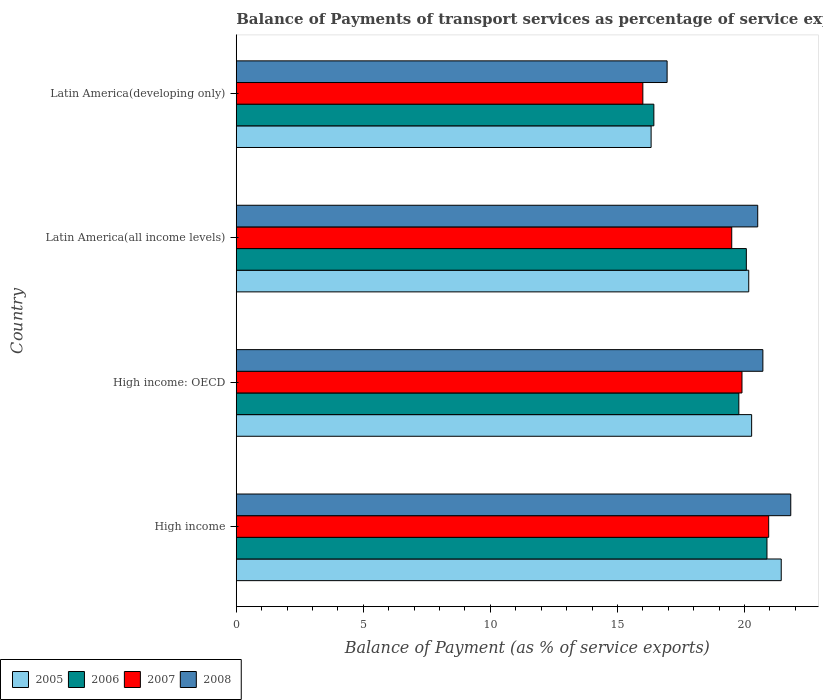How many groups of bars are there?
Offer a terse response. 4. Are the number of bars per tick equal to the number of legend labels?
Give a very brief answer. Yes. How many bars are there on the 4th tick from the bottom?
Offer a very short reply. 4. What is the label of the 4th group of bars from the top?
Your answer should be very brief. High income. What is the balance of payments of transport services in 2007 in High income?
Make the answer very short. 20.95. Across all countries, what is the maximum balance of payments of transport services in 2008?
Make the answer very short. 21.82. Across all countries, what is the minimum balance of payments of transport services in 2008?
Make the answer very short. 16.95. In which country was the balance of payments of transport services in 2006 maximum?
Make the answer very short. High income. In which country was the balance of payments of transport services in 2005 minimum?
Offer a terse response. Latin America(developing only). What is the total balance of payments of transport services in 2008 in the graph?
Make the answer very short. 80.01. What is the difference between the balance of payments of transport services in 2005 in High income and that in Latin America(all income levels)?
Keep it short and to the point. 1.28. What is the difference between the balance of payments of transport services in 2007 in Latin America(developing only) and the balance of payments of transport services in 2006 in High income: OECD?
Make the answer very short. -3.78. What is the average balance of payments of transport services in 2006 per country?
Ensure brevity in your answer.  19.29. What is the difference between the balance of payments of transport services in 2008 and balance of payments of transport services in 2007 in Latin America(all income levels)?
Your answer should be compact. 1.02. In how many countries, is the balance of payments of transport services in 2006 greater than 18 %?
Provide a short and direct response. 3. What is the ratio of the balance of payments of transport services in 2008 in High income to that in High income: OECD?
Your response must be concise. 1.05. Is the balance of payments of transport services in 2005 in High income: OECD less than that in Latin America(developing only)?
Ensure brevity in your answer.  No. Is the difference between the balance of payments of transport services in 2008 in High income: OECD and Latin America(developing only) greater than the difference between the balance of payments of transport services in 2007 in High income: OECD and Latin America(developing only)?
Offer a terse response. No. What is the difference between the highest and the second highest balance of payments of transport services in 2008?
Give a very brief answer. 1.1. What is the difference between the highest and the lowest balance of payments of transport services in 2006?
Make the answer very short. 4.45. In how many countries, is the balance of payments of transport services in 2006 greater than the average balance of payments of transport services in 2006 taken over all countries?
Ensure brevity in your answer.  3. Is the sum of the balance of payments of transport services in 2006 in Latin America(all income levels) and Latin America(developing only) greater than the maximum balance of payments of transport services in 2007 across all countries?
Keep it short and to the point. Yes. What does the 3rd bar from the bottom in High income represents?
Offer a terse response. 2007. Is it the case that in every country, the sum of the balance of payments of transport services in 2007 and balance of payments of transport services in 2005 is greater than the balance of payments of transport services in 2006?
Your answer should be very brief. Yes. How many bars are there?
Provide a succinct answer. 16. Are all the bars in the graph horizontal?
Ensure brevity in your answer.  Yes. How many countries are there in the graph?
Keep it short and to the point. 4. Where does the legend appear in the graph?
Offer a terse response. Bottom left. How many legend labels are there?
Your answer should be compact. 4. How are the legend labels stacked?
Ensure brevity in your answer.  Horizontal. What is the title of the graph?
Ensure brevity in your answer.  Balance of Payments of transport services as percentage of service exports. Does "2011" appear as one of the legend labels in the graph?
Ensure brevity in your answer.  No. What is the label or title of the X-axis?
Provide a succinct answer. Balance of Payment (as % of service exports). What is the Balance of Payment (as % of service exports) in 2005 in High income?
Your answer should be compact. 21.44. What is the Balance of Payment (as % of service exports) in 2006 in High income?
Offer a very short reply. 20.88. What is the Balance of Payment (as % of service exports) of 2007 in High income?
Provide a succinct answer. 20.95. What is the Balance of Payment (as % of service exports) of 2008 in High income?
Provide a succinct answer. 21.82. What is the Balance of Payment (as % of service exports) of 2005 in High income: OECD?
Offer a very short reply. 20.28. What is the Balance of Payment (as % of service exports) in 2006 in High income: OECD?
Give a very brief answer. 19.78. What is the Balance of Payment (as % of service exports) of 2007 in High income: OECD?
Offer a terse response. 19.9. What is the Balance of Payment (as % of service exports) of 2008 in High income: OECD?
Give a very brief answer. 20.72. What is the Balance of Payment (as % of service exports) in 2005 in Latin America(all income levels)?
Your answer should be very brief. 20.17. What is the Balance of Payment (as % of service exports) in 2006 in Latin America(all income levels)?
Offer a very short reply. 20.07. What is the Balance of Payment (as % of service exports) of 2007 in Latin America(all income levels)?
Provide a short and direct response. 19.5. What is the Balance of Payment (as % of service exports) in 2008 in Latin America(all income levels)?
Ensure brevity in your answer.  20.52. What is the Balance of Payment (as % of service exports) in 2005 in Latin America(developing only)?
Make the answer very short. 16.32. What is the Balance of Payment (as % of service exports) in 2006 in Latin America(developing only)?
Provide a succinct answer. 16.43. What is the Balance of Payment (as % of service exports) in 2007 in Latin America(developing only)?
Your answer should be compact. 16. What is the Balance of Payment (as % of service exports) in 2008 in Latin America(developing only)?
Your answer should be compact. 16.95. Across all countries, what is the maximum Balance of Payment (as % of service exports) of 2005?
Make the answer very short. 21.44. Across all countries, what is the maximum Balance of Payment (as % of service exports) in 2006?
Give a very brief answer. 20.88. Across all countries, what is the maximum Balance of Payment (as % of service exports) in 2007?
Offer a terse response. 20.95. Across all countries, what is the maximum Balance of Payment (as % of service exports) in 2008?
Offer a very short reply. 21.82. Across all countries, what is the minimum Balance of Payment (as % of service exports) in 2005?
Offer a very short reply. 16.32. Across all countries, what is the minimum Balance of Payment (as % of service exports) of 2006?
Your response must be concise. 16.43. Across all countries, what is the minimum Balance of Payment (as % of service exports) of 2007?
Your answer should be compact. 16. Across all countries, what is the minimum Balance of Payment (as % of service exports) in 2008?
Ensure brevity in your answer.  16.95. What is the total Balance of Payment (as % of service exports) of 2005 in the graph?
Provide a short and direct response. 78.21. What is the total Balance of Payment (as % of service exports) in 2006 in the graph?
Your answer should be very brief. 77.16. What is the total Balance of Payment (as % of service exports) of 2007 in the graph?
Offer a very short reply. 76.35. What is the total Balance of Payment (as % of service exports) of 2008 in the graph?
Your response must be concise. 80.01. What is the difference between the Balance of Payment (as % of service exports) in 2005 in High income and that in High income: OECD?
Keep it short and to the point. 1.16. What is the difference between the Balance of Payment (as % of service exports) in 2006 in High income and that in High income: OECD?
Offer a terse response. 1.11. What is the difference between the Balance of Payment (as % of service exports) of 2007 in High income and that in High income: OECD?
Offer a terse response. 1.05. What is the difference between the Balance of Payment (as % of service exports) of 2008 in High income and that in High income: OECD?
Provide a succinct answer. 1.1. What is the difference between the Balance of Payment (as % of service exports) in 2005 in High income and that in Latin America(all income levels)?
Ensure brevity in your answer.  1.28. What is the difference between the Balance of Payment (as % of service exports) in 2006 in High income and that in Latin America(all income levels)?
Give a very brief answer. 0.81. What is the difference between the Balance of Payment (as % of service exports) of 2007 in High income and that in Latin America(all income levels)?
Your answer should be very brief. 1.45. What is the difference between the Balance of Payment (as % of service exports) of 2008 in High income and that in Latin America(all income levels)?
Ensure brevity in your answer.  1.3. What is the difference between the Balance of Payment (as % of service exports) in 2005 in High income and that in Latin America(developing only)?
Give a very brief answer. 5.12. What is the difference between the Balance of Payment (as % of service exports) in 2006 in High income and that in Latin America(developing only)?
Your response must be concise. 4.45. What is the difference between the Balance of Payment (as % of service exports) of 2007 in High income and that in Latin America(developing only)?
Your answer should be very brief. 4.95. What is the difference between the Balance of Payment (as % of service exports) in 2008 in High income and that in Latin America(developing only)?
Ensure brevity in your answer.  4.87. What is the difference between the Balance of Payment (as % of service exports) of 2005 in High income: OECD and that in Latin America(all income levels)?
Give a very brief answer. 0.11. What is the difference between the Balance of Payment (as % of service exports) in 2006 in High income: OECD and that in Latin America(all income levels)?
Provide a succinct answer. -0.3. What is the difference between the Balance of Payment (as % of service exports) of 2007 in High income: OECD and that in Latin America(all income levels)?
Keep it short and to the point. 0.4. What is the difference between the Balance of Payment (as % of service exports) of 2008 in High income: OECD and that in Latin America(all income levels)?
Ensure brevity in your answer.  0.2. What is the difference between the Balance of Payment (as % of service exports) in 2005 in High income: OECD and that in Latin America(developing only)?
Provide a succinct answer. 3.96. What is the difference between the Balance of Payment (as % of service exports) in 2006 in High income: OECD and that in Latin America(developing only)?
Offer a terse response. 3.34. What is the difference between the Balance of Payment (as % of service exports) in 2007 in High income: OECD and that in Latin America(developing only)?
Offer a very short reply. 3.9. What is the difference between the Balance of Payment (as % of service exports) of 2008 in High income: OECD and that in Latin America(developing only)?
Offer a very short reply. 3.77. What is the difference between the Balance of Payment (as % of service exports) in 2005 in Latin America(all income levels) and that in Latin America(developing only)?
Give a very brief answer. 3.84. What is the difference between the Balance of Payment (as % of service exports) of 2006 in Latin America(all income levels) and that in Latin America(developing only)?
Ensure brevity in your answer.  3.64. What is the difference between the Balance of Payment (as % of service exports) of 2007 in Latin America(all income levels) and that in Latin America(developing only)?
Provide a succinct answer. 3.5. What is the difference between the Balance of Payment (as % of service exports) in 2008 in Latin America(all income levels) and that in Latin America(developing only)?
Provide a succinct answer. 3.57. What is the difference between the Balance of Payment (as % of service exports) of 2005 in High income and the Balance of Payment (as % of service exports) of 2006 in High income: OECD?
Your answer should be compact. 1.67. What is the difference between the Balance of Payment (as % of service exports) in 2005 in High income and the Balance of Payment (as % of service exports) in 2007 in High income: OECD?
Provide a short and direct response. 1.54. What is the difference between the Balance of Payment (as % of service exports) in 2005 in High income and the Balance of Payment (as % of service exports) in 2008 in High income: OECD?
Your answer should be compact. 0.72. What is the difference between the Balance of Payment (as % of service exports) of 2006 in High income and the Balance of Payment (as % of service exports) of 2008 in High income: OECD?
Your answer should be compact. 0.16. What is the difference between the Balance of Payment (as % of service exports) of 2007 in High income and the Balance of Payment (as % of service exports) of 2008 in High income: OECD?
Offer a terse response. 0.23. What is the difference between the Balance of Payment (as % of service exports) of 2005 in High income and the Balance of Payment (as % of service exports) of 2006 in Latin America(all income levels)?
Provide a short and direct response. 1.37. What is the difference between the Balance of Payment (as % of service exports) in 2005 in High income and the Balance of Payment (as % of service exports) in 2007 in Latin America(all income levels)?
Keep it short and to the point. 1.95. What is the difference between the Balance of Payment (as % of service exports) in 2005 in High income and the Balance of Payment (as % of service exports) in 2008 in Latin America(all income levels)?
Offer a very short reply. 0.93. What is the difference between the Balance of Payment (as % of service exports) of 2006 in High income and the Balance of Payment (as % of service exports) of 2007 in Latin America(all income levels)?
Your answer should be very brief. 1.39. What is the difference between the Balance of Payment (as % of service exports) of 2006 in High income and the Balance of Payment (as % of service exports) of 2008 in Latin America(all income levels)?
Give a very brief answer. 0.36. What is the difference between the Balance of Payment (as % of service exports) in 2007 in High income and the Balance of Payment (as % of service exports) in 2008 in Latin America(all income levels)?
Your answer should be very brief. 0.43. What is the difference between the Balance of Payment (as % of service exports) of 2005 in High income and the Balance of Payment (as % of service exports) of 2006 in Latin America(developing only)?
Your response must be concise. 5.01. What is the difference between the Balance of Payment (as % of service exports) in 2005 in High income and the Balance of Payment (as % of service exports) in 2007 in Latin America(developing only)?
Keep it short and to the point. 5.45. What is the difference between the Balance of Payment (as % of service exports) in 2005 in High income and the Balance of Payment (as % of service exports) in 2008 in Latin America(developing only)?
Keep it short and to the point. 4.49. What is the difference between the Balance of Payment (as % of service exports) in 2006 in High income and the Balance of Payment (as % of service exports) in 2007 in Latin America(developing only)?
Your answer should be compact. 4.88. What is the difference between the Balance of Payment (as % of service exports) in 2006 in High income and the Balance of Payment (as % of service exports) in 2008 in Latin America(developing only)?
Provide a short and direct response. 3.93. What is the difference between the Balance of Payment (as % of service exports) of 2007 in High income and the Balance of Payment (as % of service exports) of 2008 in Latin America(developing only)?
Provide a short and direct response. 4. What is the difference between the Balance of Payment (as % of service exports) of 2005 in High income: OECD and the Balance of Payment (as % of service exports) of 2006 in Latin America(all income levels)?
Offer a terse response. 0.21. What is the difference between the Balance of Payment (as % of service exports) in 2005 in High income: OECD and the Balance of Payment (as % of service exports) in 2007 in Latin America(all income levels)?
Your answer should be very brief. 0.78. What is the difference between the Balance of Payment (as % of service exports) in 2005 in High income: OECD and the Balance of Payment (as % of service exports) in 2008 in Latin America(all income levels)?
Provide a succinct answer. -0.24. What is the difference between the Balance of Payment (as % of service exports) of 2006 in High income: OECD and the Balance of Payment (as % of service exports) of 2007 in Latin America(all income levels)?
Make the answer very short. 0.28. What is the difference between the Balance of Payment (as % of service exports) of 2006 in High income: OECD and the Balance of Payment (as % of service exports) of 2008 in Latin America(all income levels)?
Make the answer very short. -0.74. What is the difference between the Balance of Payment (as % of service exports) of 2007 in High income: OECD and the Balance of Payment (as % of service exports) of 2008 in Latin America(all income levels)?
Your answer should be very brief. -0.62. What is the difference between the Balance of Payment (as % of service exports) in 2005 in High income: OECD and the Balance of Payment (as % of service exports) in 2006 in Latin America(developing only)?
Provide a succinct answer. 3.85. What is the difference between the Balance of Payment (as % of service exports) in 2005 in High income: OECD and the Balance of Payment (as % of service exports) in 2007 in Latin America(developing only)?
Provide a succinct answer. 4.28. What is the difference between the Balance of Payment (as % of service exports) of 2005 in High income: OECD and the Balance of Payment (as % of service exports) of 2008 in Latin America(developing only)?
Your answer should be compact. 3.33. What is the difference between the Balance of Payment (as % of service exports) of 2006 in High income: OECD and the Balance of Payment (as % of service exports) of 2007 in Latin America(developing only)?
Keep it short and to the point. 3.78. What is the difference between the Balance of Payment (as % of service exports) in 2006 in High income: OECD and the Balance of Payment (as % of service exports) in 2008 in Latin America(developing only)?
Your answer should be very brief. 2.82. What is the difference between the Balance of Payment (as % of service exports) of 2007 in High income: OECD and the Balance of Payment (as % of service exports) of 2008 in Latin America(developing only)?
Give a very brief answer. 2.95. What is the difference between the Balance of Payment (as % of service exports) of 2005 in Latin America(all income levels) and the Balance of Payment (as % of service exports) of 2006 in Latin America(developing only)?
Your answer should be very brief. 3.73. What is the difference between the Balance of Payment (as % of service exports) of 2005 in Latin America(all income levels) and the Balance of Payment (as % of service exports) of 2007 in Latin America(developing only)?
Ensure brevity in your answer.  4.17. What is the difference between the Balance of Payment (as % of service exports) in 2005 in Latin America(all income levels) and the Balance of Payment (as % of service exports) in 2008 in Latin America(developing only)?
Give a very brief answer. 3.21. What is the difference between the Balance of Payment (as % of service exports) of 2006 in Latin America(all income levels) and the Balance of Payment (as % of service exports) of 2007 in Latin America(developing only)?
Offer a terse response. 4.07. What is the difference between the Balance of Payment (as % of service exports) of 2006 in Latin America(all income levels) and the Balance of Payment (as % of service exports) of 2008 in Latin America(developing only)?
Offer a very short reply. 3.12. What is the difference between the Balance of Payment (as % of service exports) in 2007 in Latin America(all income levels) and the Balance of Payment (as % of service exports) in 2008 in Latin America(developing only)?
Ensure brevity in your answer.  2.54. What is the average Balance of Payment (as % of service exports) of 2005 per country?
Offer a very short reply. 19.55. What is the average Balance of Payment (as % of service exports) of 2006 per country?
Offer a very short reply. 19.29. What is the average Balance of Payment (as % of service exports) in 2007 per country?
Make the answer very short. 19.09. What is the average Balance of Payment (as % of service exports) of 2008 per country?
Provide a succinct answer. 20. What is the difference between the Balance of Payment (as % of service exports) of 2005 and Balance of Payment (as % of service exports) of 2006 in High income?
Provide a short and direct response. 0.56. What is the difference between the Balance of Payment (as % of service exports) in 2005 and Balance of Payment (as % of service exports) in 2007 in High income?
Offer a terse response. 0.49. What is the difference between the Balance of Payment (as % of service exports) of 2005 and Balance of Payment (as % of service exports) of 2008 in High income?
Provide a short and direct response. -0.37. What is the difference between the Balance of Payment (as % of service exports) in 2006 and Balance of Payment (as % of service exports) in 2007 in High income?
Make the answer very short. -0.07. What is the difference between the Balance of Payment (as % of service exports) of 2006 and Balance of Payment (as % of service exports) of 2008 in High income?
Offer a very short reply. -0.94. What is the difference between the Balance of Payment (as % of service exports) in 2007 and Balance of Payment (as % of service exports) in 2008 in High income?
Provide a succinct answer. -0.87. What is the difference between the Balance of Payment (as % of service exports) of 2005 and Balance of Payment (as % of service exports) of 2006 in High income: OECD?
Provide a succinct answer. 0.5. What is the difference between the Balance of Payment (as % of service exports) of 2005 and Balance of Payment (as % of service exports) of 2007 in High income: OECD?
Provide a short and direct response. 0.38. What is the difference between the Balance of Payment (as % of service exports) of 2005 and Balance of Payment (as % of service exports) of 2008 in High income: OECD?
Offer a terse response. -0.44. What is the difference between the Balance of Payment (as % of service exports) of 2006 and Balance of Payment (as % of service exports) of 2007 in High income: OECD?
Provide a short and direct response. -0.12. What is the difference between the Balance of Payment (as % of service exports) in 2006 and Balance of Payment (as % of service exports) in 2008 in High income: OECD?
Make the answer very short. -0.95. What is the difference between the Balance of Payment (as % of service exports) in 2007 and Balance of Payment (as % of service exports) in 2008 in High income: OECD?
Your answer should be very brief. -0.82. What is the difference between the Balance of Payment (as % of service exports) in 2005 and Balance of Payment (as % of service exports) in 2006 in Latin America(all income levels)?
Your response must be concise. 0.09. What is the difference between the Balance of Payment (as % of service exports) in 2005 and Balance of Payment (as % of service exports) in 2007 in Latin America(all income levels)?
Keep it short and to the point. 0.67. What is the difference between the Balance of Payment (as % of service exports) of 2005 and Balance of Payment (as % of service exports) of 2008 in Latin America(all income levels)?
Your response must be concise. -0.35. What is the difference between the Balance of Payment (as % of service exports) of 2006 and Balance of Payment (as % of service exports) of 2007 in Latin America(all income levels)?
Offer a terse response. 0.57. What is the difference between the Balance of Payment (as % of service exports) of 2006 and Balance of Payment (as % of service exports) of 2008 in Latin America(all income levels)?
Ensure brevity in your answer.  -0.45. What is the difference between the Balance of Payment (as % of service exports) of 2007 and Balance of Payment (as % of service exports) of 2008 in Latin America(all income levels)?
Keep it short and to the point. -1.02. What is the difference between the Balance of Payment (as % of service exports) of 2005 and Balance of Payment (as % of service exports) of 2006 in Latin America(developing only)?
Give a very brief answer. -0.11. What is the difference between the Balance of Payment (as % of service exports) of 2005 and Balance of Payment (as % of service exports) of 2007 in Latin America(developing only)?
Your answer should be very brief. 0.33. What is the difference between the Balance of Payment (as % of service exports) of 2005 and Balance of Payment (as % of service exports) of 2008 in Latin America(developing only)?
Provide a succinct answer. -0.63. What is the difference between the Balance of Payment (as % of service exports) in 2006 and Balance of Payment (as % of service exports) in 2007 in Latin America(developing only)?
Offer a very short reply. 0.43. What is the difference between the Balance of Payment (as % of service exports) of 2006 and Balance of Payment (as % of service exports) of 2008 in Latin America(developing only)?
Provide a succinct answer. -0.52. What is the difference between the Balance of Payment (as % of service exports) in 2007 and Balance of Payment (as % of service exports) in 2008 in Latin America(developing only)?
Provide a short and direct response. -0.95. What is the ratio of the Balance of Payment (as % of service exports) of 2005 in High income to that in High income: OECD?
Provide a short and direct response. 1.06. What is the ratio of the Balance of Payment (as % of service exports) in 2006 in High income to that in High income: OECD?
Give a very brief answer. 1.06. What is the ratio of the Balance of Payment (as % of service exports) of 2007 in High income to that in High income: OECD?
Provide a succinct answer. 1.05. What is the ratio of the Balance of Payment (as % of service exports) in 2008 in High income to that in High income: OECD?
Offer a terse response. 1.05. What is the ratio of the Balance of Payment (as % of service exports) in 2005 in High income to that in Latin America(all income levels)?
Provide a succinct answer. 1.06. What is the ratio of the Balance of Payment (as % of service exports) in 2006 in High income to that in Latin America(all income levels)?
Offer a terse response. 1.04. What is the ratio of the Balance of Payment (as % of service exports) of 2007 in High income to that in Latin America(all income levels)?
Your response must be concise. 1.07. What is the ratio of the Balance of Payment (as % of service exports) in 2008 in High income to that in Latin America(all income levels)?
Offer a very short reply. 1.06. What is the ratio of the Balance of Payment (as % of service exports) of 2005 in High income to that in Latin America(developing only)?
Make the answer very short. 1.31. What is the ratio of the Balance of Payment (as % of service exports) in 2006 in High income to that in Latin America(developing only)?
Offer a very short reply. 1.27. What is the ratio of the Balance of Payment (as % of service exports) in 2007 in High income to that in Latin America(developing only)?
Provide a short and direct response. 1.31. What is the ratio of the Balance of Payment (as % of service exports) in 2008 in High income to that in Latin America(developing only)?
Your response must be concise. 1.29. What is the ratio of the Balance of Payment (as % of service exports) of 2006 in High income: OECD to that in Latin America(all income levels)?
Keep it short and to the point. 0.99. What is the ratio of the Balance of Payment (as % of service exports) in 2007 in High income: OECD to that in Latin America(all income levels)?
Keep it short and to the point. 1.02. What is the ratio of the Balance of Payment (as % of service exports) of 2008 in High income: OECD to that in Latin America(all income levels)?
Make the answer very short. 1.01. What is the ratio of the Balance of Payment (as % of service exports) in 2005 in High income: OECD to that in Latin America(developing only)?
Provide a succinct answer. 1.24. What is the ratio of the Balance of Payment (as % of service exports) of 2006 in High income: OECD to that in Latin America(developing only)?
Offer a terse response. 1.2. What is the ratio of the Balance of Payment (as % of service exports) of 2007 in High income: OECD to that in Latin America(developing only)?
Provide a short and direct response. 1.24. What is the ratio of the Balance of Payment (as % of service exports) in 2008 in High income: OECD to that in Latin America(developing only)?
Provide a short and direct response. 1.22. What is the ratio of the Balance of Payment (as % of service exports) of 2005 in Latin America(all income levels) to that in Latin America(developing only)?
Provide a succinct answer. 1.24. What is the ratio of the Balance of Payment (as % of service exports) of 2006 in Latin America(all income levels) to that in Latin America(developing only)?
Keep it short and to the point. 1.22. What is the ratio of the Balance of Payment (as % of service exports) in 2007 in Latin America(all income levels) to that in Latin America(developing only)?
Your answer should be very brief. 1.22. What is the ratio of the Balance of Payment (as % of service exports) in 2008 in Latin America(all income levels) to that in Latin America(developing only)?
Give a very brief answer. 1.21. What is the difference between the highest and the second highest Balance of Payment (as % of service exports) in 2005?
Give a very brief answer. 1.16. What is the difference between the highest and the second highest Balance of Payment (as % of service exports) of 2006?
Keep it short and to the point. 0.81. What is the difference between the highest and the second highest Balance of Payment (as % of service exports) in 2007?
Make the answer very short. 1.05. What is the difference between the highest and the second highest Balance of Payment (as % of service exports) of 2008?
Your answer should be very brief. 1.1. What is the difference between the highest and the lowest Balance of Payment (as % of service exports) of 2005?
Keep it short and to the point. 5.12. What is the difference between the highest and the lowest Balance of Payment (as % of service exports) of 2006?
Give a very brief answer. 4.45. What is the difference between the highest and the lowest Balance of Payment (as % of service exports) in 2007?
Keep it short and to the point. 4.95. What is the difference between the highest and the lowest Balance of Payment (as % of service exports) in 2008?
Offer a terse response. 4.87. 